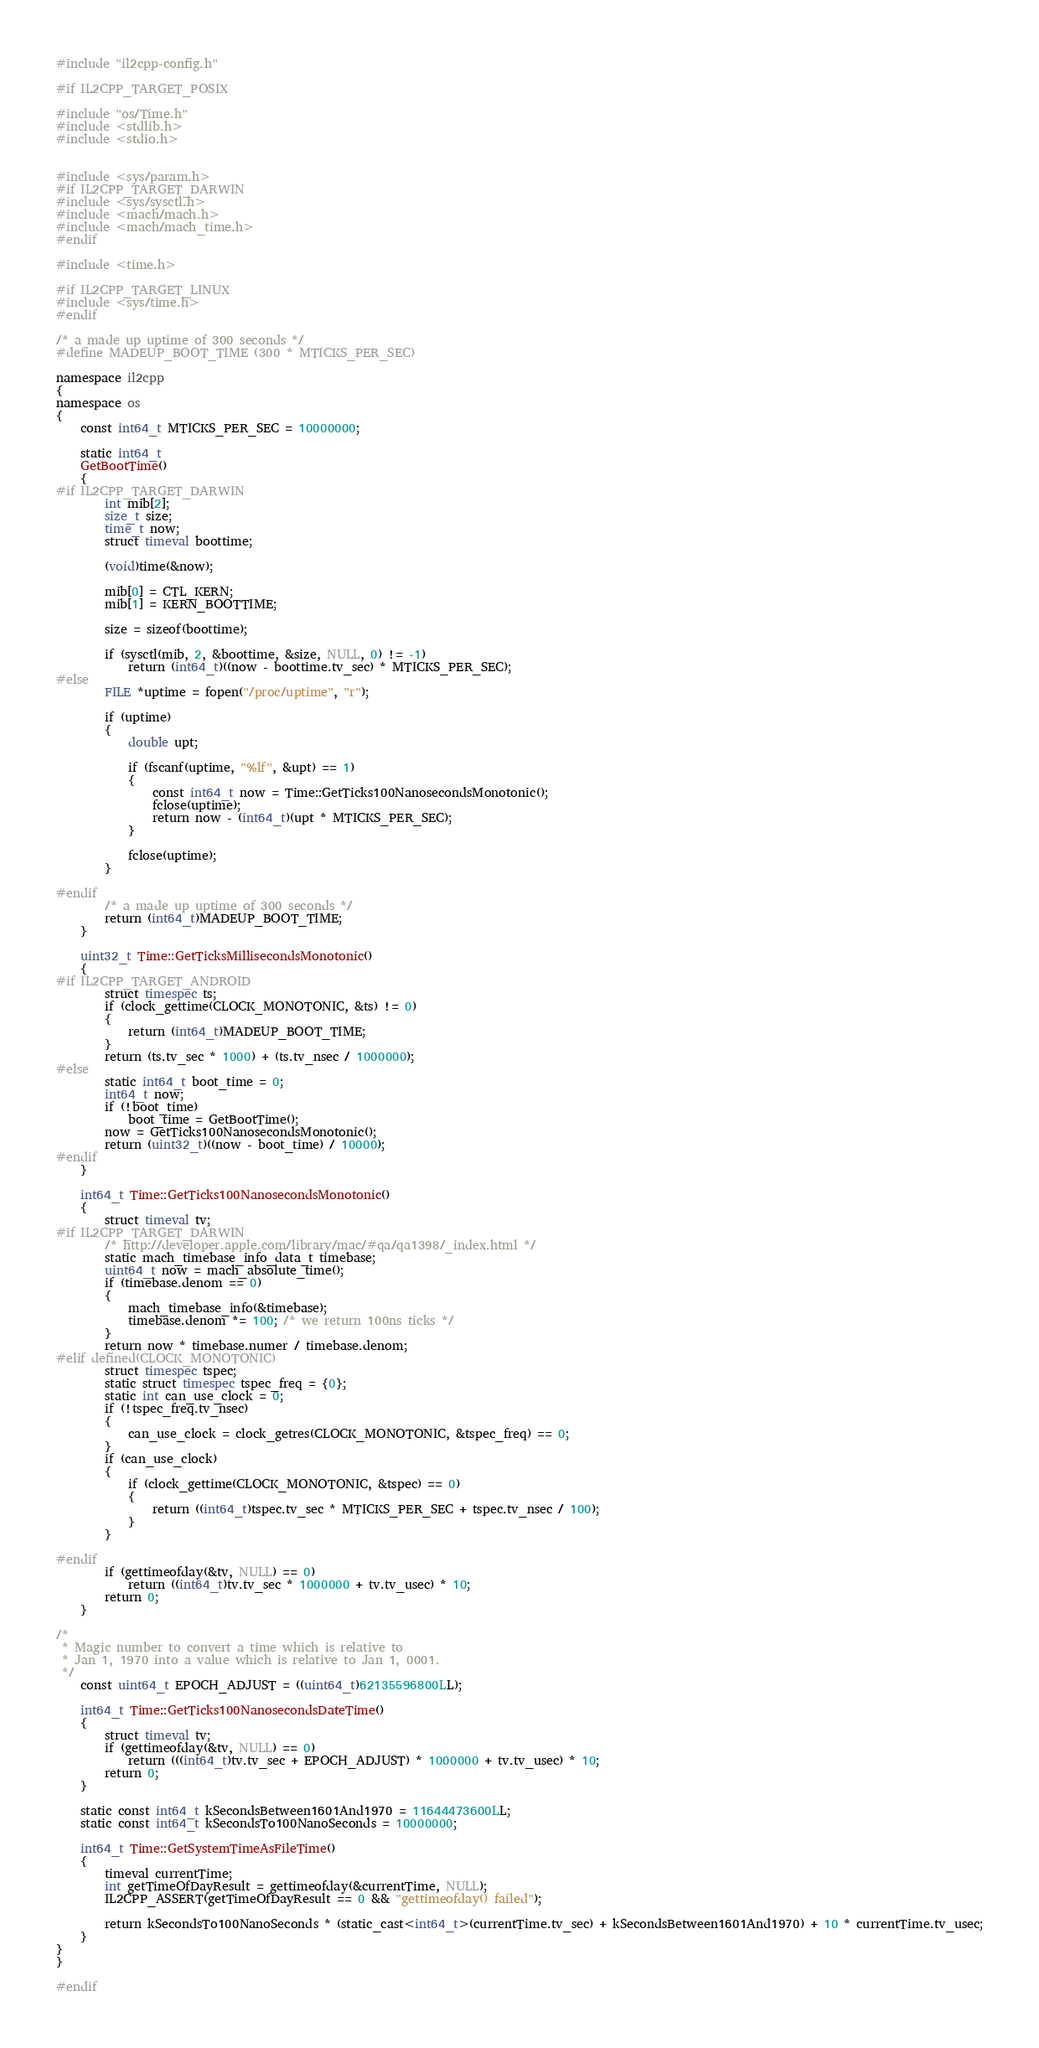<code> <loc_0><loc_0><loc_500><loc_500><_C++_>#include "il2cpp-config.h"

#if IL2CPP_TARGET_POSIX

#include "os/Time.h"
#include <stdlib.h>
#include <stdio.h>


#include <sys/param.h>
#if IL2CPP_TARGET_DARWIN
#include <sys/sysctl.h>
#include <mach/mach.h>
#include <mach/mach_time.h>
#endif

#include <time.h>

#if IL2CPP_TARGET_LINUX
#include <sys/time.h>
#endif

/* a made up uptime of 300 seconds */
#define MADEUP_BOOT_TIME (300 * MTICKS_PER_SEC)

namespace il2cpp
{
namespace os
{
    const int64_t MTICKS_PER_SEC = 10000000;

    static int64_t
    GetBootTime()
    {
#if IL2CPP_TARGET_DARWIN
        int mib[2];
        size_t size;
        time_t now;
        struct timeval boottime;

        (void)time(&now);

        mib[0] = CTL_KERN;
        mib[1] = KERN_BOOTTIME;

        size = sizeof(boottime);

        if (sysctl(mib, 2, &boottime, &size, NULL, 0) != -1)
            return (int64_t)((now - boottime.tv_sec) * MTICKS_PER_SEC);
#else
        FILE *uptime = fopen("/proc/uptime", "r");

        if (uptime)
        {
            double upt;

            if (fscanf(uptime, "%lf", &upt) == 1)
            {
                const int64_t now = Time::GetTicks100NanosecondsMonotonic();
                fclose(uptime);
                return now - (int64_t)(upt * MTICKS_PER_SEC);
            }

            fclose(uptime);
        }

#endif
        /* a made up uptime of 300 seconds */
        return (int64_t)MADEUP_BOOT_TIME;
    }

    uint32_t Time::GetTicksMillisecondsMonotonic()
    {
#if IL2CPP_TARGET_ANDROID
        struct timespec ts;
        if (clock_gettime(CLOCK_MONOTONIC, &ts) != 0)
        {
            return (int64_t)MADEUP_BOOT_TIME;
        }
        return (ts.tv_sec * 1000) + (ts.tv_nsec / 1000000);
#else
        static int64_t boot_time = 0;
        int64_t now;
        if (!boot_time)
            boot_time = GetBootTime();
        now = GetTicks100NanosecondsMonotonic();
        return (uint32_t)((now - boot_time) / 10000);
#endif
    }

    int64_t Time::GetTicks100NanosecondsMonotonic()
    {
        struct timeval tv;
#if IL2CPP_TARGET_DARWIN
        /* http://developer.apple.com/library/mac/#qa/qa1398/_index.html */
        static mach_timebase_info_data_t timebase;
        uint64_t now = mach_absolute_time();
        if (timebase.denom == 0)
        {
            mach_timebase_info(&timebase);
            timebase.denom *= 100; /* we return 100ns ticks */
        }
        return now * timebase.numer / timebase.denom;
#elif defined(CLOCK_MONOTONIC)
        struct timespec tspec;
        static struct timespec tspec_freq = {0};
        static int can_use_clock = 0;
        if (!tspec_freq.tv_nsec)
        {
            can_use_clock = clock_getres(CLOCK_MONOTONIC, &tspec_freq) == 0;
        }
        if (can_use_clock)
        {
            if (clock_gettime(CLOCK_MONOTONIC, &tspec) == 0)
            {
                return ((int64_t)tspec.tv_sec * MTICKS_PER_SEC + tspec.tv_nsec / 100);
            }
        }

#endif
        if (gettimeofday(&tv, NULL) == 0)
            return ((int64_t)tv.tv_sec * 1000000 + tv.tv_usec) * 10;
        return 0;
    }

/*
 * Magic number to convert a time which is relative to
 * Jan 1, 1970 into a value which is relative to Jan 1, 0001.
 */
    const uint64_t EPOCH_ADJUST = ((uint64_t)62135596800LL);

    int64_t Time::GetTicks100NanosecondsDateTime()
    {
        struct timeval tv;
        if (gettimeofday(&tv, NULL) == 0)
            return (((int64_t)tv.tv_sec + EPOCH_ADJUST) * 1000000 + tv.tv_usec) * 10;
        return 0;
    }

    static const int64_t kSecondsBetween1601And1970 = 11644473600LL;
    static const int64_t kSecondsTo100NanoSeconds = 10000000;

    int64_t Time::GetSystemTimeAsFileTime()
    {
        timeval currentTime;
        int getTimeOfDayResult = gettimeofday(&currentTime, NULL);
        IL2CPP_ASSERT(getTimeOfDayResult == 0 && "gettimeofday() failed");

        return kSecondsTo100NanoSeconds * (static_cast<int64_t>(currentTime.tv_sec) + kSecondsBetween1601And1970) + 10 * currentTime.tv_usec;
    }
}
}

#endif
</code> 